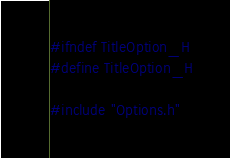Convert code to text. <code><loc_0><loc_0><loc_500><loc_500><_C_>#ifndef TitleOption_H
#define TitleOption_H

#include "Options.h"
</code> 